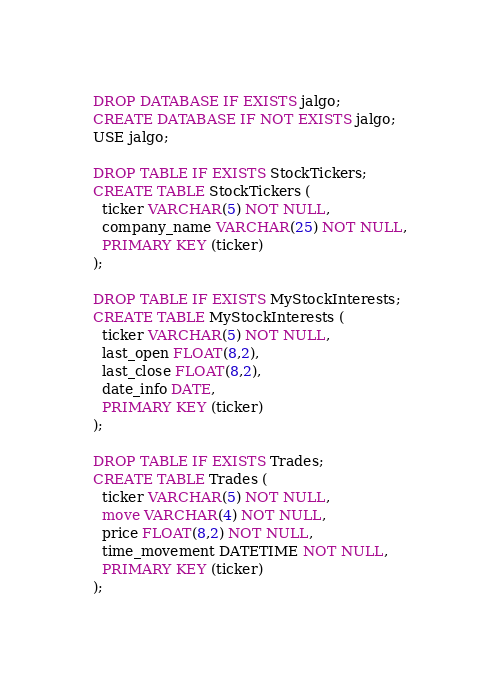<code> <loc_0><loc_0><loc_500><loc_500><_SQL_>DROP DATABASE IF EXISTS jalgo;
CREATE DATABASE IF NOT EXISTS jalgo;
USE jalgo;

DROP TABLE IF EXISTS StockTickers;
CREATE TABLE StockTickers (
  ticker VARCHAR(5) NOT NULL,
  company_name VARCHAR(25) NOT NULL,
  PRIMARY KEY (ticker)
);

DROP TABLE IF EXISTS MyStockInterests;
CREATE TABLE MyStockInterests (
  ticker VARCHAR(5) NOT NULL,
  last_open FLOAT(8,2),
  last_close FLOAT(8,2),
  date_info DATE,
  PRIMARY KEY (ticker)
);

DROP TABLE IF EXISTS Trades;
CREATE TABLE Trades (
  ticker VARCHAR(5) NOT NULL,
  move VARCHAR(4) NOT NULL,
  price FLOAT(8,2) NOT NULL,
  time_movement DATETIME NOT NULL,
  PRIMARY KEY (ticker)
);
</code> 